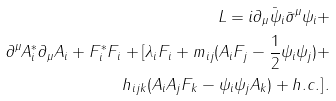<formula> <loc_0><loc_0><loc_500><loc_500>L = i \partial _ { \mu } \bar { \psi } _ { i } \bar { \sigma } ^ { \mu } \psi _ { i } + \\ \partial ^ { \mu } A ^ { * } _ { i } \partial _ { \mu } A _ { i } + F ^ { * } _ { i } F _ { i } + [ \lambda _ { i } F _ { i } + m _ { i j } ( A _ { i } F _ { j } - \frac { 1 } { 2 } \psi _ { i } \psi _ { j } ) + \\ h _ { i j k } ( A _ { i } A _ { j } F _ { k } - \psi _ { i } \psi _ { j } A _ { k } ) + h . c . ] \, .</formula> 